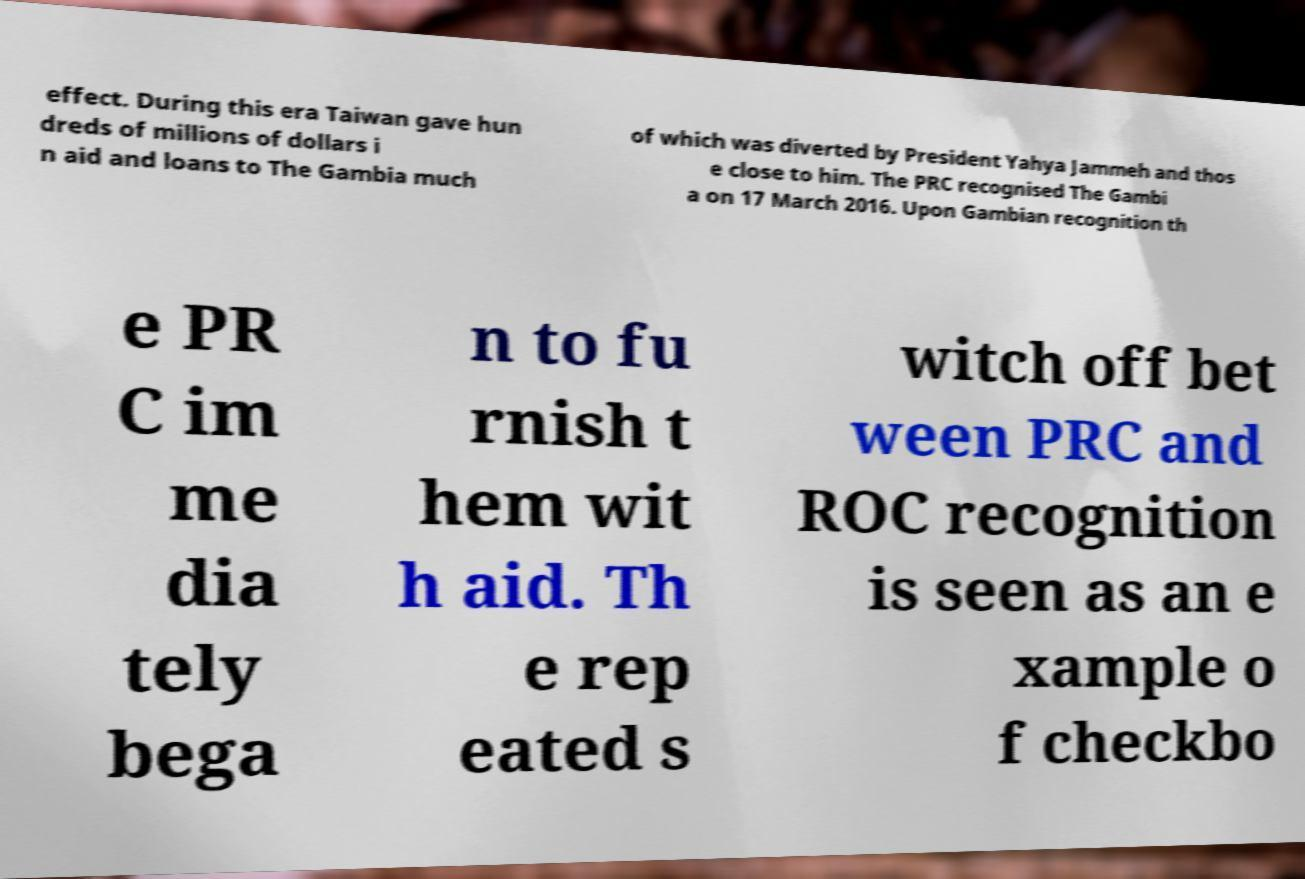Please identify and transcribe the text found in this image. effect. During this era Taiwan gave hun dreds of millions of dollars i n aid and loans to The Gambia much of which was diverted by President Yahya Jammeh and thos e close to him. The PRC recognised The Gambi a on 17 March 2016. Upon Gambian recognition th e PR C im me dia tely bega n to fu rnish t hem wit h aid. Th e rep eated s witch off bet ween PRC and ROC recognition is seen as an e xample o f checkbo 